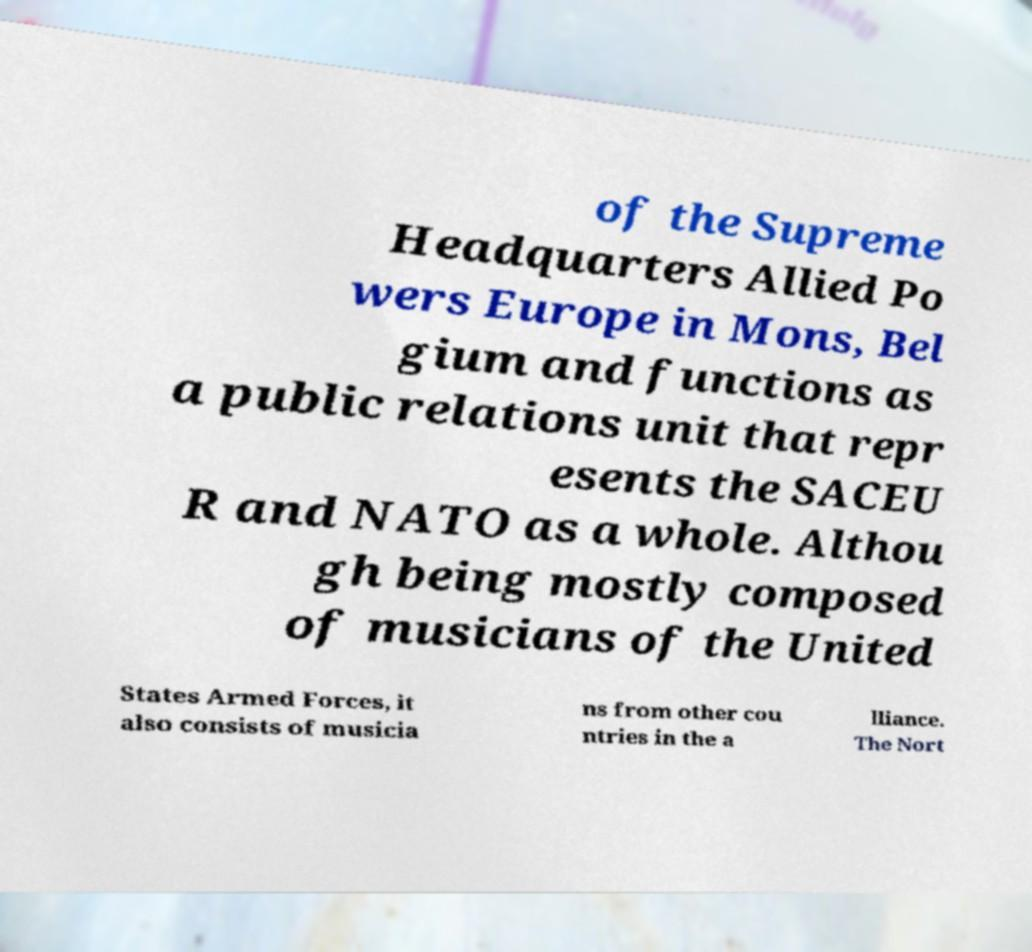Could you assist in decoding the text presented in this image and type it out clearly? of the Supreme Headquarters Allied Po wers Europe in Mons, Bel gium and functions as a public relations unit that repr esents the SACEU R and NATO as a whole. Althou gh being mostly composed of musicians of the United States Armed Forces, it also consists of musicia ns from other cou ntries in the a lliance. The Nort 